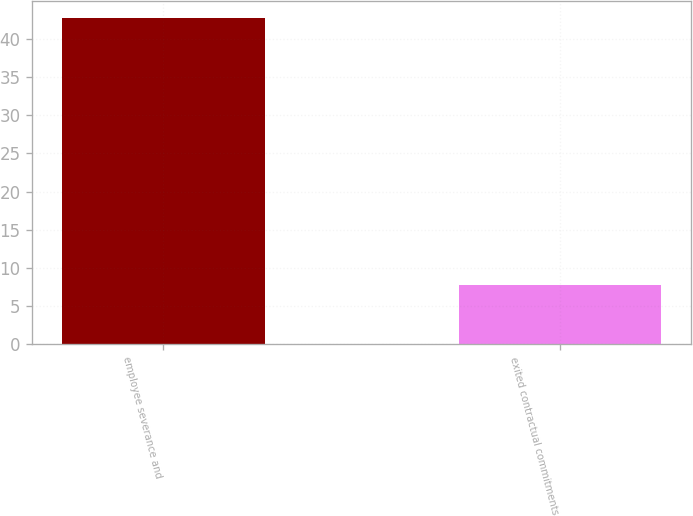Convert chart to OTSL. <chart><loc_0><loc_0><loc_500><loc_500><bar_chart><fcel>employee severance and<fcel>exited contractual commitments<nl><fcel>42.8<fcel>7.7<nl></chart> 